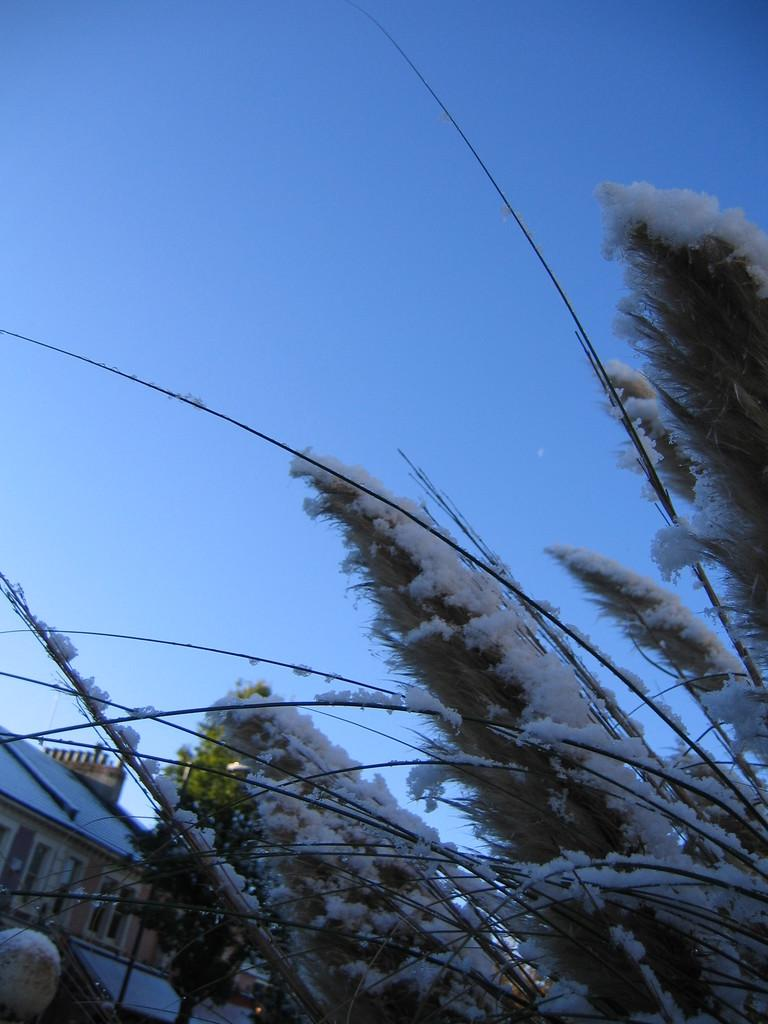What type of structure is present in the image? There is a building in the image. What natural element is covered with snow in the image? There is a tree covered with snow in the image. What can be seen in the background of the image? The sky is visible in the background of the image. Where is the playground located in the image? There is no playground present in the image. How many wings can be seen on the building in the image? The building in the image does not have any visible wings. 